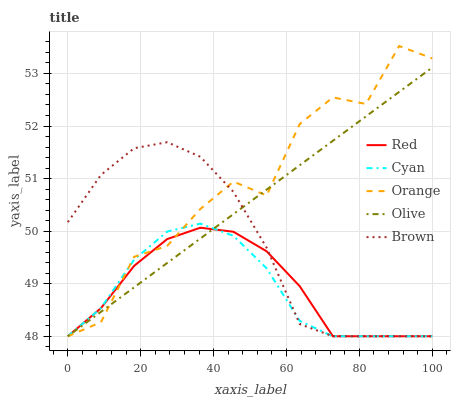Does Cyan have the minimum area under the curve?
Answer yes or no. Yes. Does Orange have the maximum area under the curve?
Answer yes or no. Yes. Does Brown have the minimum area under the curve?
Answer yes or no. No. Does Brown have the maximum area under the curve?
Answer yes or no. No. Is Olive the smoothest?
Answer yes or no. Yes. Is Orange the roughest?
Answer yes or no. Yes. Is Cyan the smoothest?
Answer yes or no. No. Is Cyan the roughest?
Answer yes or no. No. Does Orange have the lowest value?
Answer yes or no. Yes. Does Orange have the highest value?
Answer yes or no. Yes. Does Cyan have the highest value?
Answer yes or no. No. Does Orange intersect Cyan?
Answer yes or no. Yes. Is Orange less than Cyan?
Answer yes or no. No. Is Orange greater than Cyan?
Answer yes or no. No. 